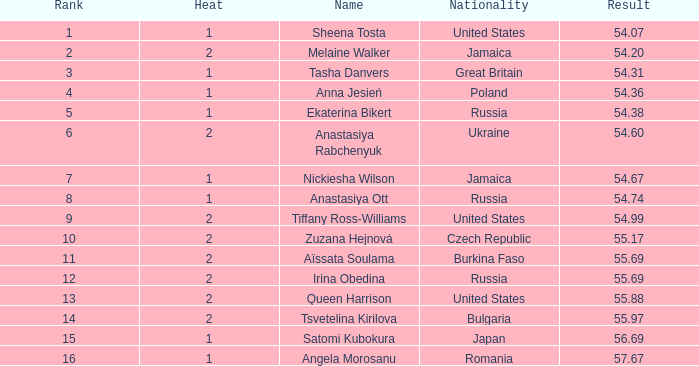97? None. Can you parse all the data within this table? {'header': ['Rank', 'Heat', 'Name', 'Nationality', 'Result'], 'rows': [['1', '1', 'Sheena Tosta', 'United States', '54.07'], ['2', '2', 'Melaine Walker', 'Jamaica', '54.20'], ['3', '1', 'Tasha Danvers', 'Great Britain', '54.31'], ['4', '1', 'Anna Jesień', 'Poland', '54.36'], ['5', '1', 'Ekaterina Bikert', 'Russia', '54.38'], ['6', '2', 'Anastasiya Rabchenyuk', 'Ukraine', '54.60'], ['7', '1', 'Nickiesha Wilson', 'Jamaica', '54.67'], ['8', '1', 'Anastasiya Ott', 'Russia', '54.74'], ['9', '2', 'Tiffany Ross-Williams', 'United States', '54.99'], ['10', '2', 'Zuzana Hejnová', 'Czech Republic', '55.17'], ['11', '2', 'Aïssata Soulama', 'Burkina Faso', '55.69'], ['12', '2', 'Irina Obedina', 'Russia', '55.69'], ['13', '2', 'Queen Harrison', 'United States', '55.88'], ['14', '2', 'Tsvetelina Kirilova', 'Bulgaria', '55.97'], ['15', '1', 'Satomi Kubokura', 'Japan', '56.69'], ['16', '1', 'Angela Morosanu', 'Romania', '57.67']]} 